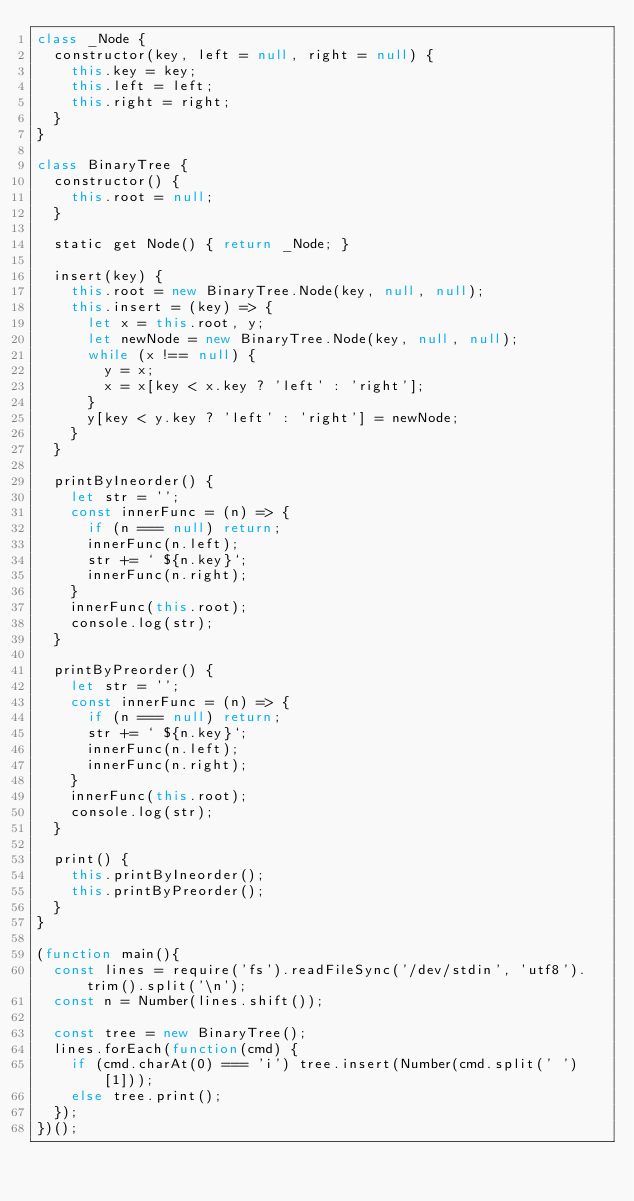<code> <loc_0><loc_0><loc_500><loc_500><_JavaScript_>class _Node {
  constructor(key, left = null, right = null) {
    this.key = key;
    this.left = left;
    this.right = right;
  }
}

class BinaryTree {
  constructor() {
    this.root = null;
  }

  static get Node() { return _Node; }

  insert(key) {
    this.root = new BinaryTree.Node(key, null, null);
    this.insert = (key) => {
      let x = this.root, y;
      let newNode = new BinaryTree.Node(key, null, null);
      while (x !== null) {
        y = x;
        x = x[key < x.key ? 'left' : 'right'];
      }
      y[key < y.key ? 'left' : 'right'] = newNode;
    }
  }

  printByIneorder() {
    let str = '';
    const innerFunc = (n) => {
      if (n === null) return;
      innerFunc(n.left);
      str += ` ${n.key}`;
      innerFunc(n.right);
    }
    innerFunc(this.root);
    console.log(str);
  }

  printByPreorder() {
    let str = '';
    const innerFunc = (n) => {
      if (n === null) return;
      str += ` ${n.key}`;
      innerFunc(n.left);
      innerFunc(n.right);
    }
    innerFunc(this.root);
    console.log(str);
  }

  print() {
    this.printByIneorder();
    this.printByPreorder();
  }
}

(function main(){
  const lines = require('fs').readFileSync('/dev/stdin', 'utf8').trim().split('\n');
  const n = Number(lines.shift());

  const tree = new BinaryTree();
  lines.forEach(function(cmd) {
    if (cmd.charAt(0) === 'i') tree.insert(Number(cmd.split(' ')[1]));
    else tree.print();
  });
})();

</code> 